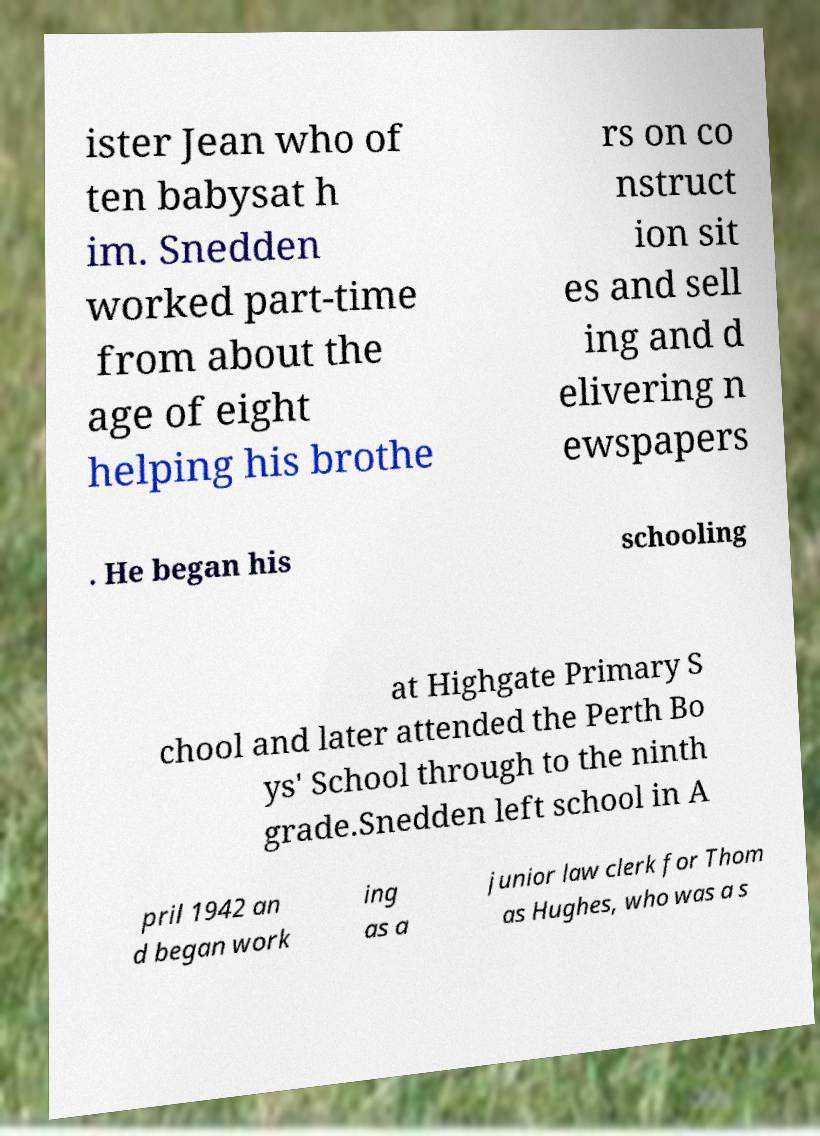Please identify and transcribe the text found in this image. ister Jean who of ten babysat h im. Snedden worked part-time from about the age of eight helping his brothe rs on co nstruct ion sit es and sell ing and d elivering n ewspapers . He began his schooling at Highgate Primary S chool and later attended the Perth Bo ys' School through to the ninth grade.Snedden left school in A pril 1942 an d began work ing as a junior law clerk for Thom as Hughes, who was a s 